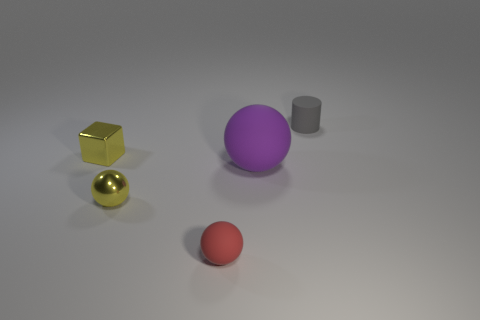The object that is on the left side of the red rubber ball and in front of the big purple rubber thing has what shape?
Provide a short and direct response. Sphere. What number of things are yellow blocks or objects to the right of the tiny yellow ball?
Your response must be concise. 4. What is the color of the cylinder that is the same material as the purple ball?
Keep it short and to the point. Gray. How many tiny red things have the same material as the cube?
Make the answer very short. 0. How many small gray shiny things are there?
Your answer should be compact. 0. Does the object that is left of the yellow ball have the same color as the small thing behind the cube?
Provide a short and direct response. No. There is a red matte object; what number of small metal objects are on the left side of it?
Your response must be concise. 2. There is a tiny block that is the same color as the tiny metal sphere; what is it made of?
Your answer should be very brief. Metal. Is there a yellow shiny object that has the same shape as the tiny gray thing?
Make the answer very short. No. Do the tiny yellow thing left of the tiny metal ball and the ball that is to the right of the tiny red thing have the same material?
Provide a short and direct response. No. 